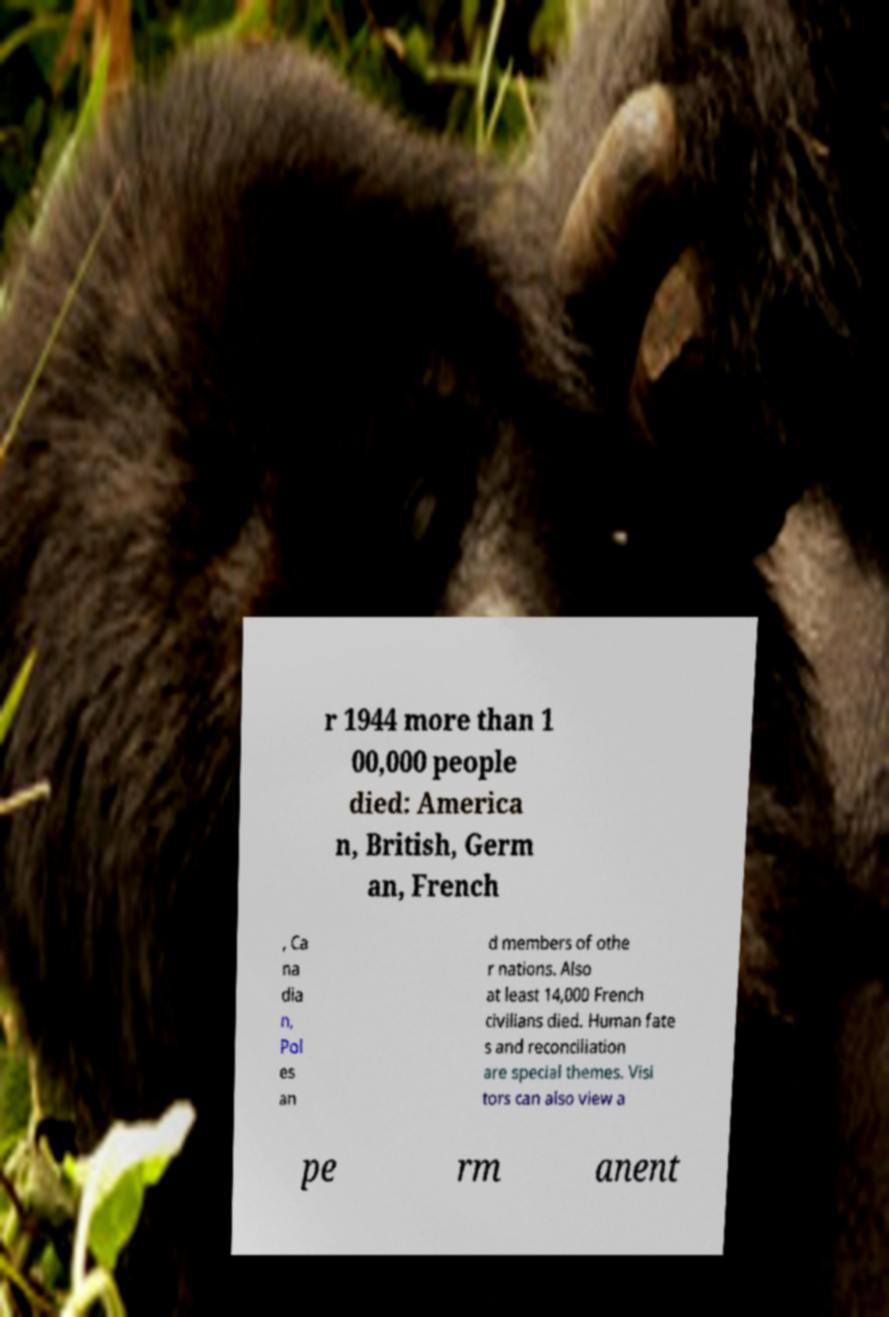Could you assist in decoding the text presented in this image and type it out clearly? r 1944 more than 1 00,000 people died: America n, British, Germ an, French , Ca na dia n, Pol es an d members of othe r nations. Also at least 14,000 French civilians died. Human fate s and reconciliation are special themes. Visi tors can also view a pe rm anent 